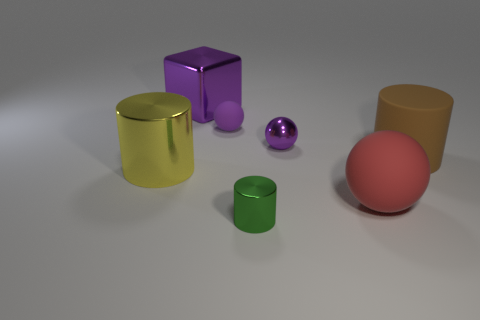Are there fewer small matte balls that are right of the green object than small balls that are to the right of the big matte ball?
Your answer should be very brief. No. What is the size of the purple ball that is the same material as the big red ball?
Your answer should be compact. Small. Is there anything else of the same color as the large rubber cylinder?
Give a very brief answer. No. Does the large brown cylinder have the same material as the tiny sphere that is on the right side of the tiny green shiny cylinder?
Give a very brief answer. No. There is a yellow thing that is the same shape as the brown object; what is it made of?
Offer a very short reply. Metal. Are there any other things that are the same material as the large purple block?
Provide a short and direct response. Yes. Is the material of the tiny object in front of the yellow thing the same as the big object behind the matte cylinder?
Offer a very short reply. Yes. There is a large shiny thing in front of the purple metallic object to the right of the tiny thing in front of the big yellow object; what color is it?
Offer a terse response. Yellow. What number of other things are the same shape as the big brown thing?
Offer a very short reply. 2. Is the large ball the same color as the large metallic cylinder?
Give a very brief answer. No. 